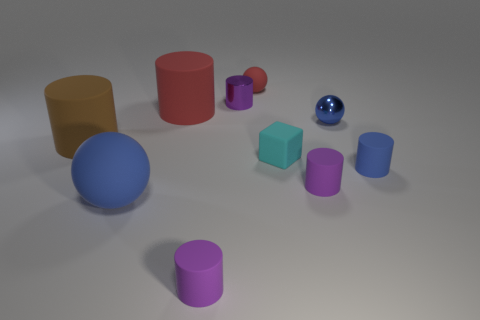Do the purple metallic thing and the brown matte cylinder have the same size?
Your response must be concise. No. What number of things are either cyan cubes that are right of the big blue matte sphere or tiny matte spheres?
Offer a terse response. 2. What is the material of the tiny cylinder that is right of the blue object behind the large brown cylinder?
Offer a very short reply. Rubber. Are there any big green metallic objects that have the same shape as the large brown object?
Your answer should be compact. No. There is a shiny ball; is it the same size as the rubber ball in front of the big brown thing?
Ensure brevity in your answer.  No. What number of things are either balls that are behind the tiny blue metal sphere or small purple cylinders in front of the blue shiny thing?
Give a very brief answer. 3. Are there more brown things that are behind the purple shiny cylinder than shiny balls?
Provide a short and direct response. No. How many metallic balls are the same size as the cyan object?
Provide a succinct answer. 1. There is a blue ball that is behind the brown cylinder; is its size the same as the purple rubber cylinder that is to the right of the red rubber ball?
Provide a succinct answer. Yes. There is a blue rubber thing that is left of the red cylinder; how big is it?
Give a very brief answer. Large. 